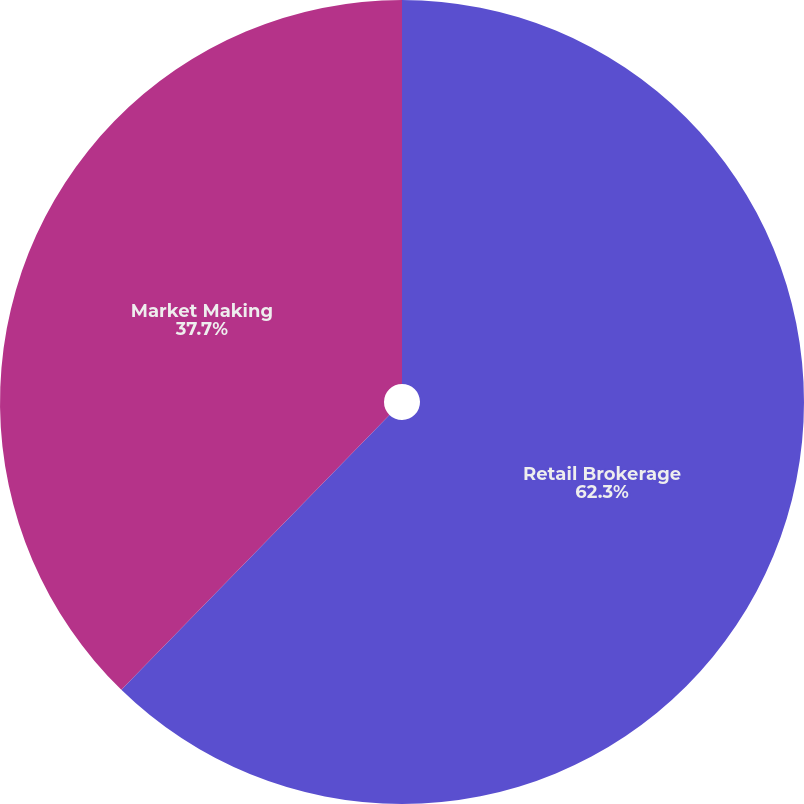<chart> <loc_0><loc_0><loc_500><loc_500><pie_chart><fcel>Retail Brokerage<fcel>Market Making<nl><fcel>62.3%<fcel>37.7%<nl></chart> 